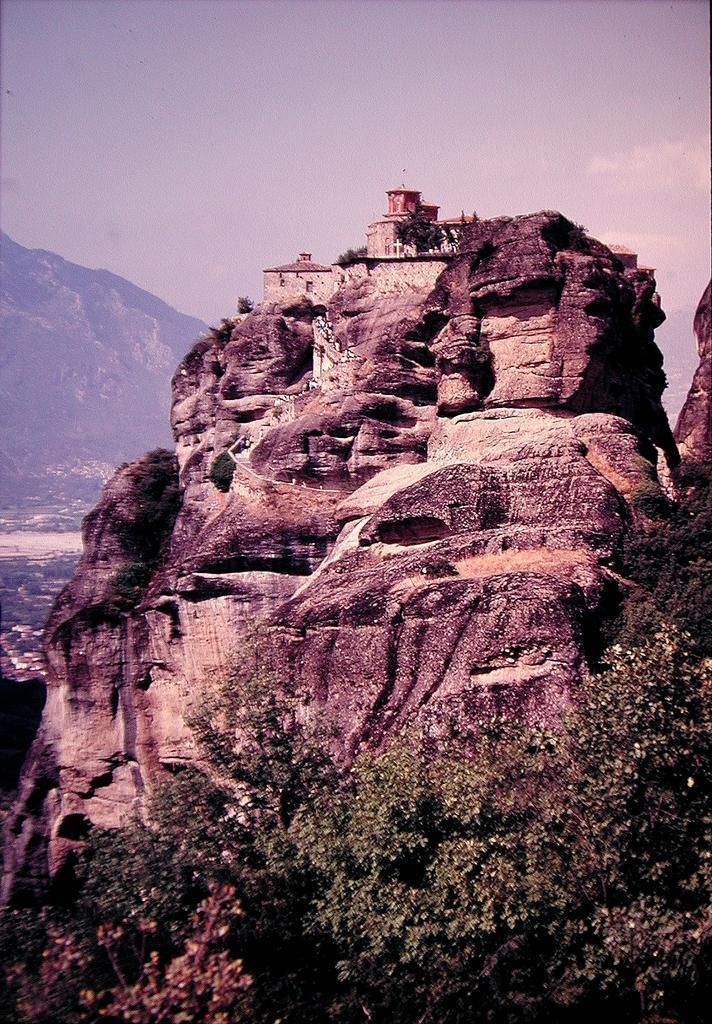Please provide a concise description of this image. In this image we can see many trees. There are few houses and many hills in the image. There is a blue and cloudy sky in the image. 